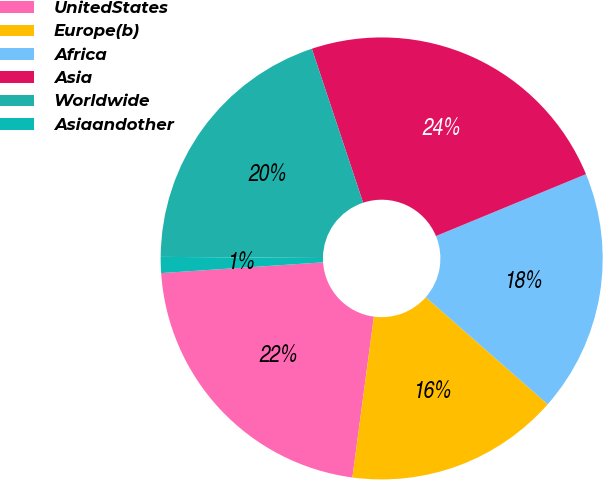Convert chart to OTSL. <chart><loc_0><loc_0><loc_500><loc_500><pie_chart><fcel>UnitedStates<fcel>Europe(b)<fcel>Africa<fcel>Asia<fcel>Worldwide<fcel>Asiaandother<nl><fcel>21.83%<fcel>15.64%<fcel>17.7%<fcel>23.89%<fcel>19.77%<fcel>1.17%<nl></chart> 